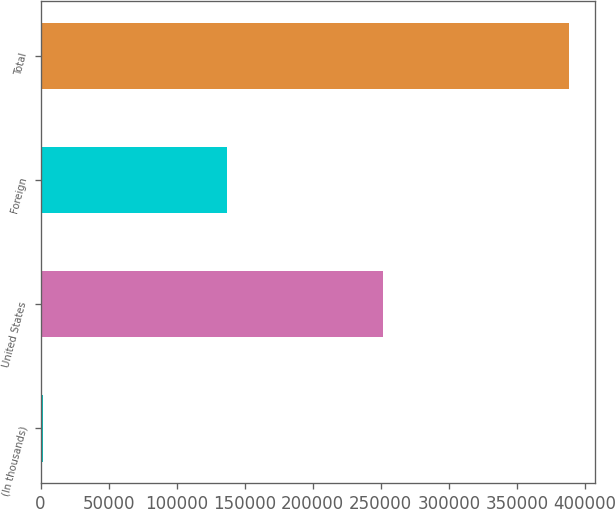<chart> <loc_0><loc_0><loc_500><loc_500><bar_chart><fcel>(In thousands)<fcel>United States<fcel>Foreign<fcel>Total<nl><fcel>2016<fcel>251321<fcel>136961<fcel>388282<nl></chart> 